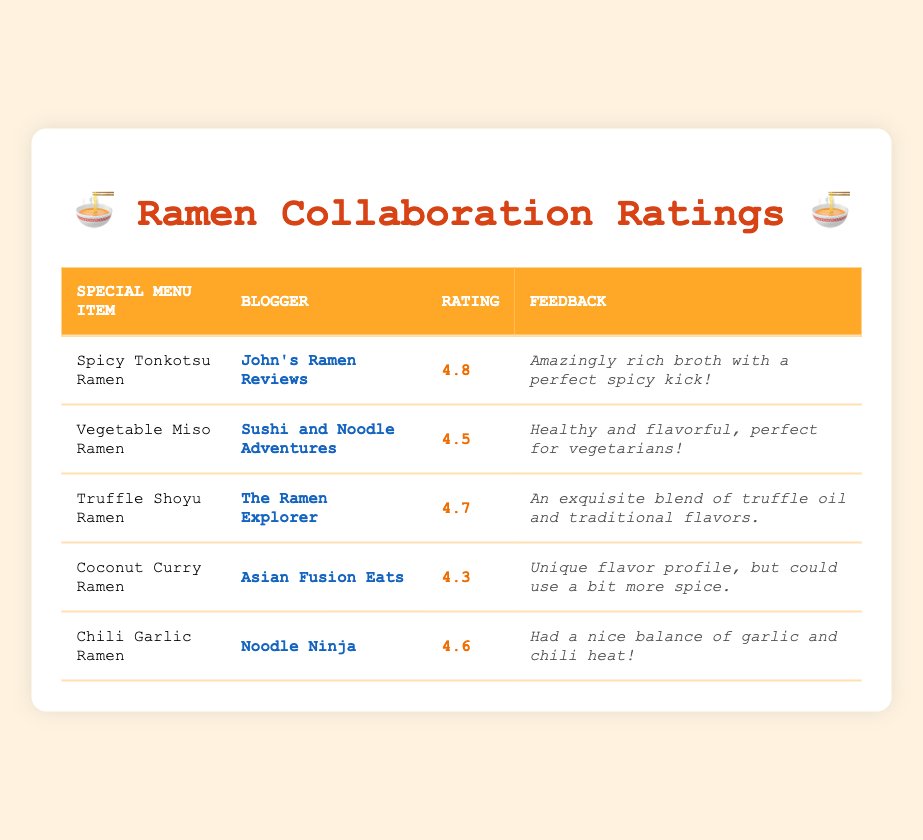What's the rating of the Spicy Tonkotsu Ramen? The table shows that the rating for Spicy Tonkotsu Ramen is listed in the third column, which is 4.8.
Answer: 4.8 Which blogger reviewed the Coconut Curry Ramen? By looking in the second column for Coconut Curry Ramen, we can see that it was reviewed by Asian Fusion Eats.
Answer: Asian Fusion Eats What is the average rating of all special menu items? First, we add up the ratings: 4.8 + 4.5 + 4.7 + 4.3 + 4.6 = 22.9. Then, divide this sum by the total number of items (5), which gives us 22.9 / 5 = 4.58.
Answer: 4.58 Did any blogger give a rating of 5 or higher? By checking each rating in the table, we find that none of the ratings exceed 4.8, meaning no blogger rated any item 5 or higher.
Answer: No Which special menu item received the lowest rating? We can see from the ratings that Coconut Curry Ramen has the lowest score of 4.3 when comparing all the ratings in the third column.
Answer: Coconut Curry Ramen What was the feedback for the Truffle Shoyu Ramen? The feedback for Truffle Shoyu Ramen is under the fourth column, which states it is "An exquisite blend of truffle oil and traditional flavors."
Answer: An exquisite blend of truffle oil and traditional flavors How many bloggers rated the special menu items mentioned? There are 5 unique bloggers listed in the second column for each of the 5 special menu items, indicating that 5 different bloggers reviewed the dishes.
Answer: 5 Which blogger gave the highest rating for their reviewed item? By examining the ratings, we can see that John's Ramen Reviews rated their item, Spicy Tonkotsu Ramen, the highest at 4.8 compared to the others.
Answer: John's Ramen Reviews Is the feedback for the Vegetable Miso Ramen positive? The feedback states it's "Healthy and flavorful, perfect for vegetarians!" which implies a positive sentiment overall. Therefore, the answer is yes.
Answer: Yes 